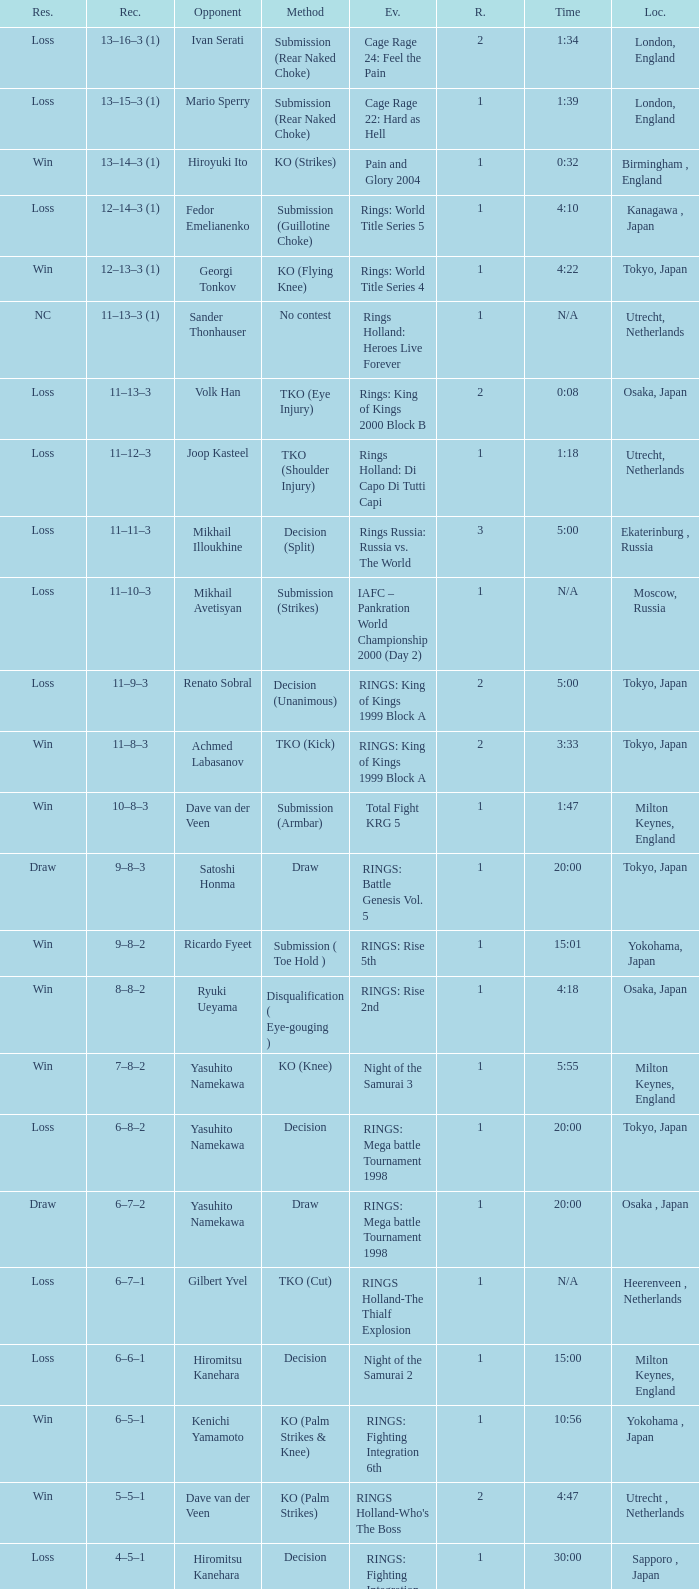Which event had an opponent of Yasuhito Namekawa with a decision method? RINGS: Mega battle Tournament 1998. 